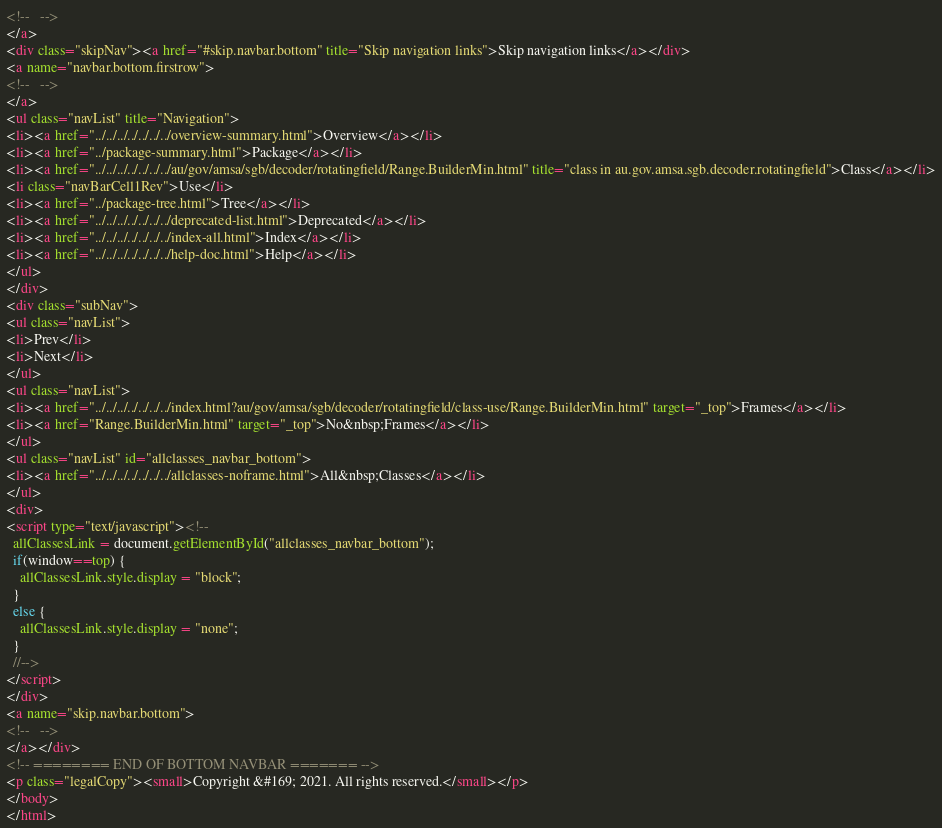<code> <loc_0><loc_0><loc_500><loc_500><_HTML_><!--   -->
</a>
<div class="skipNav"><a href="#skip.navbar.bottom" title="Skip navigation links">Skip navigation links</a></div>
<a name="navbar.bottom.firstrow">
<!--   -->
</a>
<ul class="navList" title="Navigation">
<li><a href="../../../../../../../overview-summary.html">Overview</a></li>
<li><a href="../package-summary.html">Package</a></li>
<li><a href="../../../../../../../au/gov/amsa/sgb/decoder/rotatingfield/Range.BuilderMin.html" title="class in au.gov.amsa.sgb.decoder.rotatingfield">Class</a></li>
<li class="navBarCell1Rev">Use</li>
<li><a href="../package-tree.html">Tree</a></li>
<li><a href="../../../../../../../deprecated-list.html">Deprecated</a></li>
<li><a href="../../../../../../../index-all.html">Index</a></li>
<li><a href="../../../../../../../help-doc.html">Help</a></li>
</ul>
</div>
<div class="subNav">
<ul class="navList">
<li>Prev</li>
<li>Next</li>
</ul>
<ul class="navList">
<li><a href="../../../../../../../index.html?au/gov/amsa/sgb/decoder/rotatingfield/class-use/Range.BuilderMin.html" target="_top">Frames</a></li>
<li><a href="Range.BuilderMin.html" target="_top">No&nbsp;Frames</a></li>
</ul>
<ul class="navList" id="allclasses_navbar_bottom">
<li><a href="../../../../../../../allclasses-noframe.html">All&nbsp;Classes</a></li>
</ul>
<div>
<script type="text/javascript"><!--
  allClassesLink = document.getElementById("allclasses_navbar_bottom");
  if(window==top) {
    allClassesLink.style.display = "block";
  }
  else {
    allClassesLink.style.display = "none";
  }
  //-->
</script>
</div>
<a name="skip.navbar.bottom">
<!--   -->
</a></div>
<!-- ======== END OF BOTTOM NAVBAR ======= -->
<p class="legalCopy"><small>Copyright &#169; 2021. All rights reserved.</small></p>
</body>
</html>
</code> 